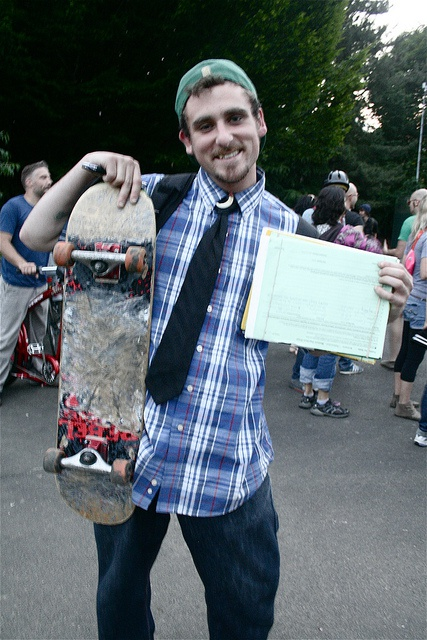Describe the objects in this image and their specific colors. I can see people in black, lightgray, gray, and darkgray tones, skateboard in black, darkgray, gray, and lightgray tones, people in black, darkgray, gray, and navy tones, tie in black, navy, lightgray, and blue tones, and bicycle in black, gray, maroon, and darkgray tones in this image. 